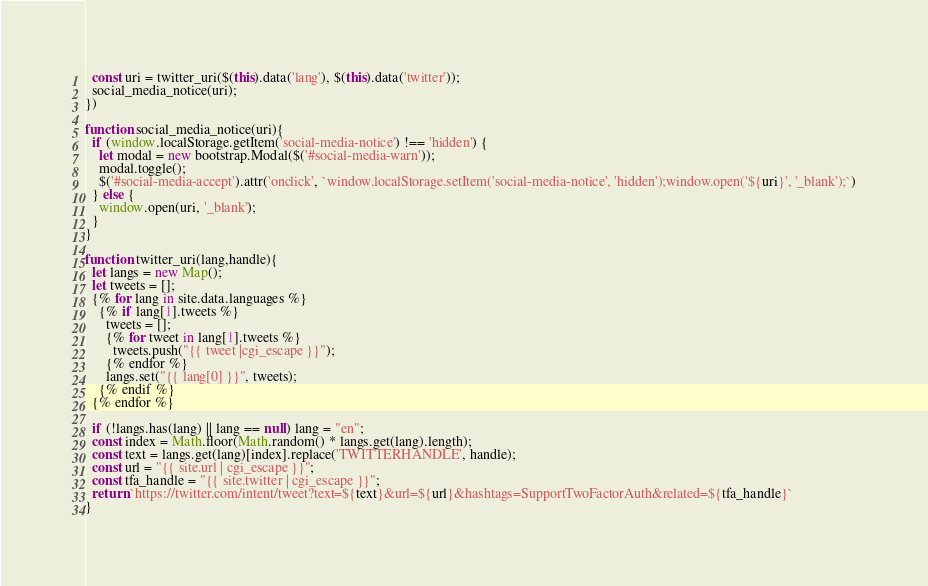<code> <loc_0><loc_0><loc_500><loc_500><_JavaScript_>  const uri = twitter_uri($(this).data('lang'), $(this).data('twitter'));
  social_media_notice(uri);
})

function social_media_notice(uri){
  if (window.localStorage.getItem('social-media-notice') !== 'hidden') {
    let modal = new bootstrap.Modal($('#social-media-warn'));
    modal.toggle();
    $('#social-media-accept').attr('onclick', `window.localStorage.setItem('social-media-notice', 'hidden');window.open('${uri}', '_blank');`)
  } else {
    window.open(uri, '_blank');
  }
}

function twitter_uri(lang,handle){
  let langs = new Map();
  let tweets = [];
  {% for lang in site.data.languages %}
    {% if lang[1].tweets %}
      tweets = [];
      {% for tweet in lang[1].tweets %}
        tweets.push("{{ tweet |cgi_escape }}");
      {% endfor %}
      langs.set("{{ lang[0] }}", tweets);
    {% endif %}
  {% endfor %}

  if (!langs.has(lang) || lang == null) lang = "en";
  const index = Math.floor(Math.random() * langs.get(lang).length);
  const text = langs.get(lang)[index].replace('TWITTERHANDLE', handle);
  const url = "{{ site.url | cgi_escape }}";
  const tfa_handle = "{{ site.twitter | cgi_escape }}";
  return `https://twitter.com/intent/tweet?text=${text}&url=${url}&hashtags=SupportTwoFactorAuth&related=${tfa_handle}`
}
</code> 